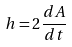Convert formula to latex. <formula><loc_0><loc_0><loc_500><loc_500>h = 2 \frac { d A } { d t }</formula> 